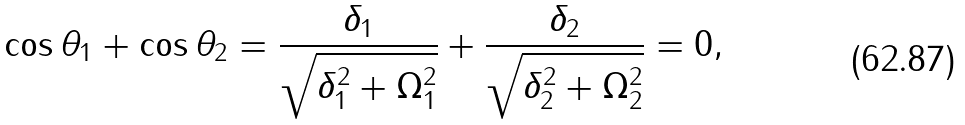Convert formula to latex. <formula><loc_0><loc_0><loc_500><loc_500>\cos \theta _ { 1 } + \cos \theta _ { 2 } = \frac { \delta _ { 1 } } { \sqrt { \delta _ { 1 } ^ { 2 } + \Omega _ { 1 } ^ { 2 } } } + \frac { \delta _ { 2 } } { \sqrt { \delta _ { 2 } ^ { 2 } + \Omega _ { 2 } ^ { 2 } } } = 0 ,</formula> 